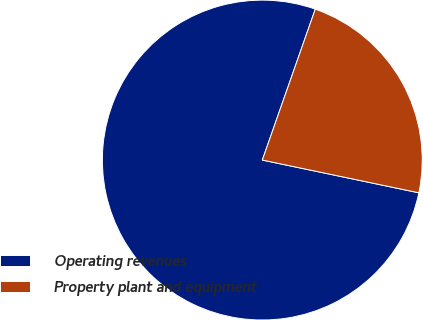<chart> <loc_0><loc_0><loc_500><loc_500><pie_chart><fcel>Operating revenues<fcel>Property plant and equipment<nl><fcel>77.09%<fcel>22.91%<nl></chart> 